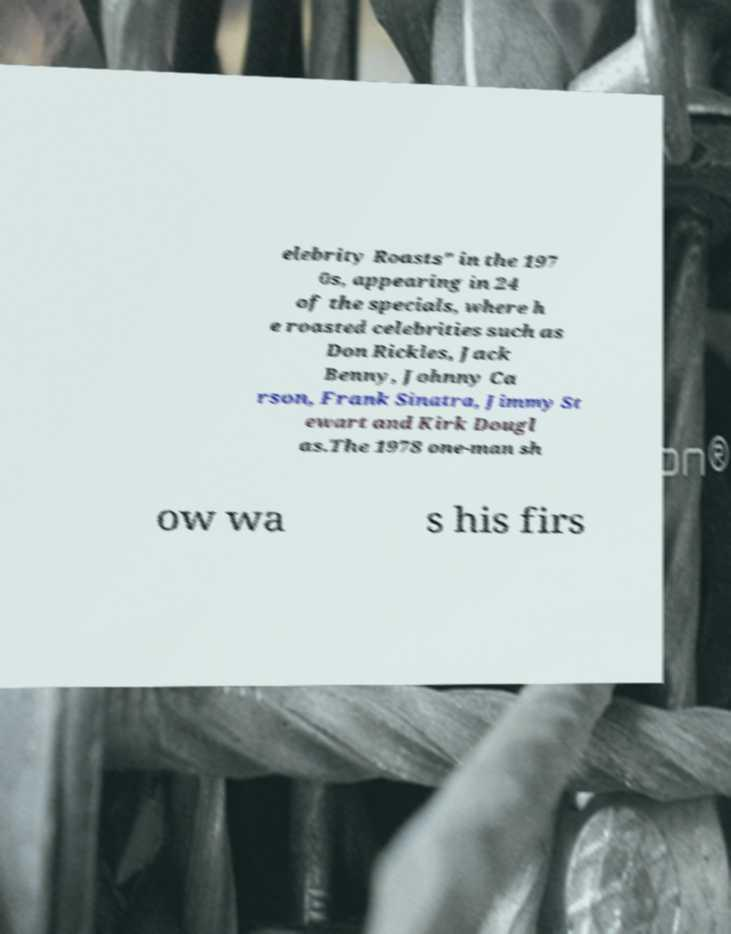What messages or text are displayed in this image? I need them in a readable, typed format. elebrity Roasts" in the 197 0s, appearing in 24 of the specials, where h e roasted celebrities such as Don Rickles, Jack Benny, Johnny Ca rson, Frank Sinatra, Jimmy St ewart and Kirk Dougl as.The 1978 one-man sh ow wa s his firs 